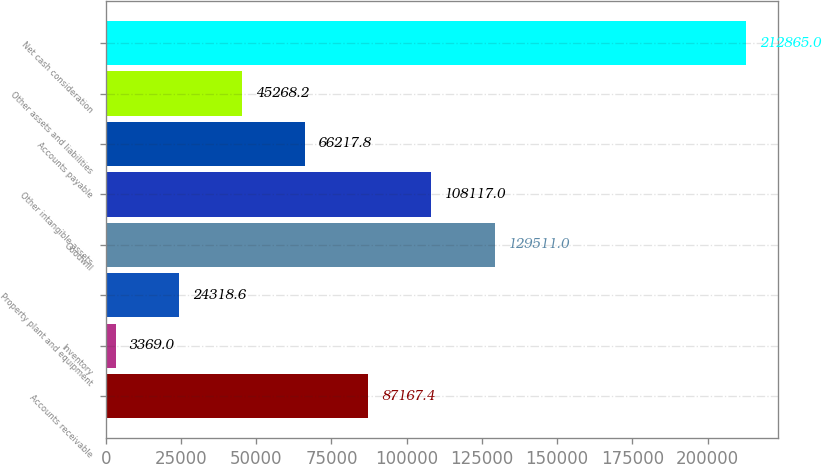<chart> <loc_0><loc_0><loc_500><loc_500><bar_chart><fcel>Accounts receivable<fcel>Inventory<fcel>Property plant and equipment<fcel>Goodwill<fcel>Other intangible assets<fcel>Accounts payable<fcel>Other assets and liabilities<fcel>Net cash consideration<nl><fcel>87167.4<fcel>3369<fcel>24318.6<fcel>129511<fcel>108117<fcel>66217.8<fcel>45268.2<fcel>212865<nl></chart> 